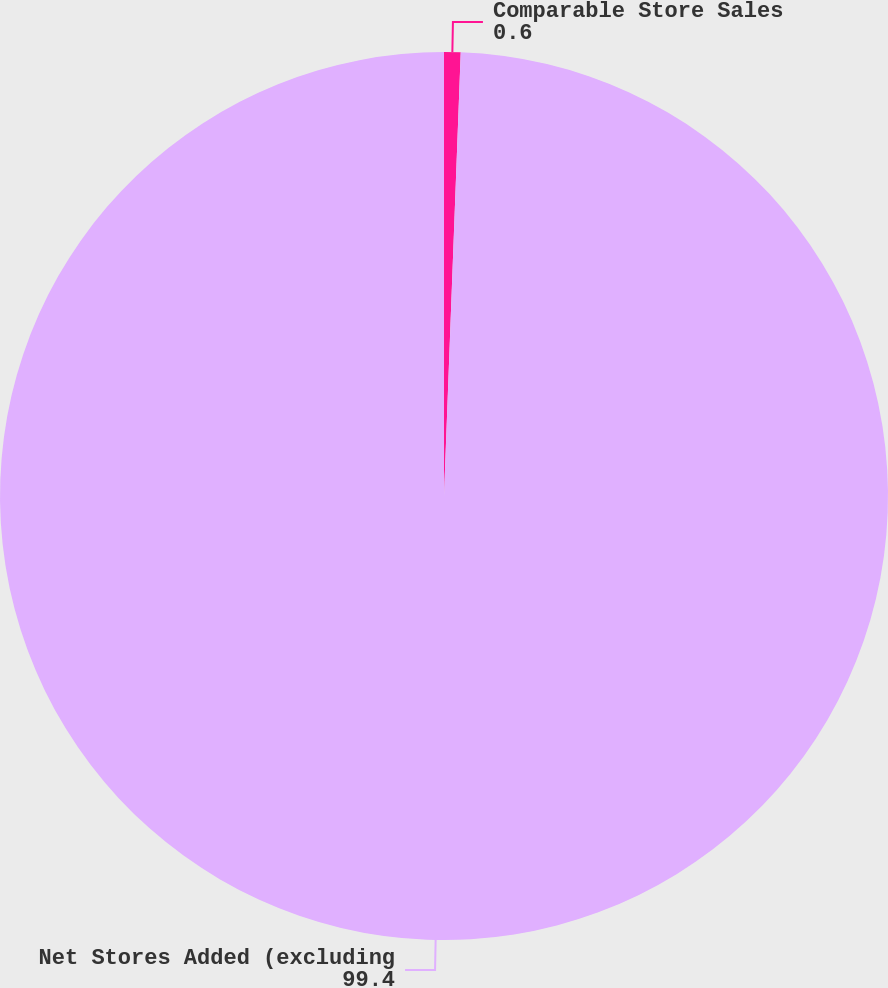Convert chart. <chart><loc_0><loc_0><loc_500><loc_500><pie_chart><fcel>Comparable Store Sales<fcel>Net Stores Added (excluding<nl><fcel>0.6%<fcel>99.4%<nl></chart> 